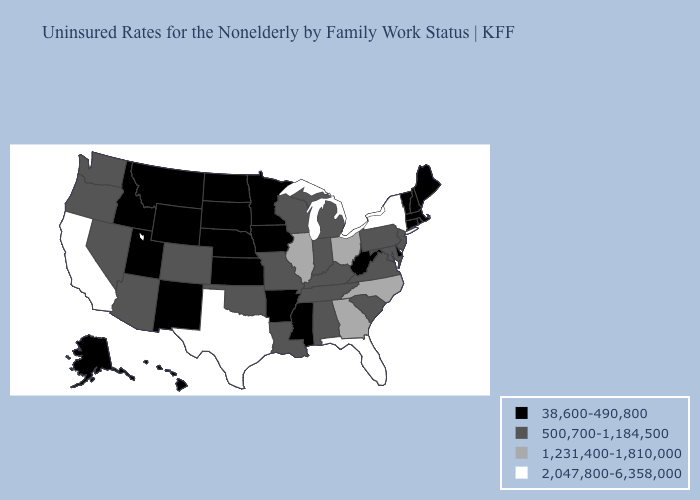Name the states that have a value in the range 2,047,800-6,358,000?
Answer briefly. California, Florida, New York, Texas. Which states have the lowest value in the West?
Concise answer only. Alaska, Hawaii, Idaho, Montana, New Mexico, Utah, Wyoming. Name the states that have a value in the range 1,231,400-1,810,000?
Keep it brief. Georgia, Illinois, North Carolina, Ohio. What is the value of Oklahoma?
Give a very brief answer. 500,700-1,184,500. Does Texas have the highest value in the USA?
Answer briefly. Yes. Does Arkansas have the same value as Michigan?
Give a very brief answer. No. Does Missouri have a lower value than North Carolina?
Concise answer only. Yes. What is the highest value in states that border Mississippi?
Quick response, please. 500,700-1,184,500. What is the highest value in the USA?
Short answer required. 2,047,800-6,358,000. What is the highest value in the West ?
Quick response, please. 2,047,800-6,358,000. Name the states that have a value in the range 500,700-1,184,500?
Give a very brief answer. Alabama, Arizona, Colorado, Indiana, Kentucky, Louisiana, Maryland, Michigan, Missouri, Nevada, New Jersey, Oklahoma, Oregon, Pennsylvania, South Carolina, Tennessee, Virginia, Washington, Wisconsin. What is the value of Mississippi?
Answer briefly. 38,600-490,800. Name the states that have a value in the range 500,700-1,184,500?
Write a very short answer. Alabama, Arizona, Colorado, Indiana, Kentucky, Louisiana, Maryland, Michigan, Missouri, Nevada, New Jersey, Oklahoma, Oregon, Pennsylvania, South Carolina, Tennessee, Virginia, Washington, Wisconsin. What is the value of Illinois?
Quick response, please. 1,231,400-1,810,000. 